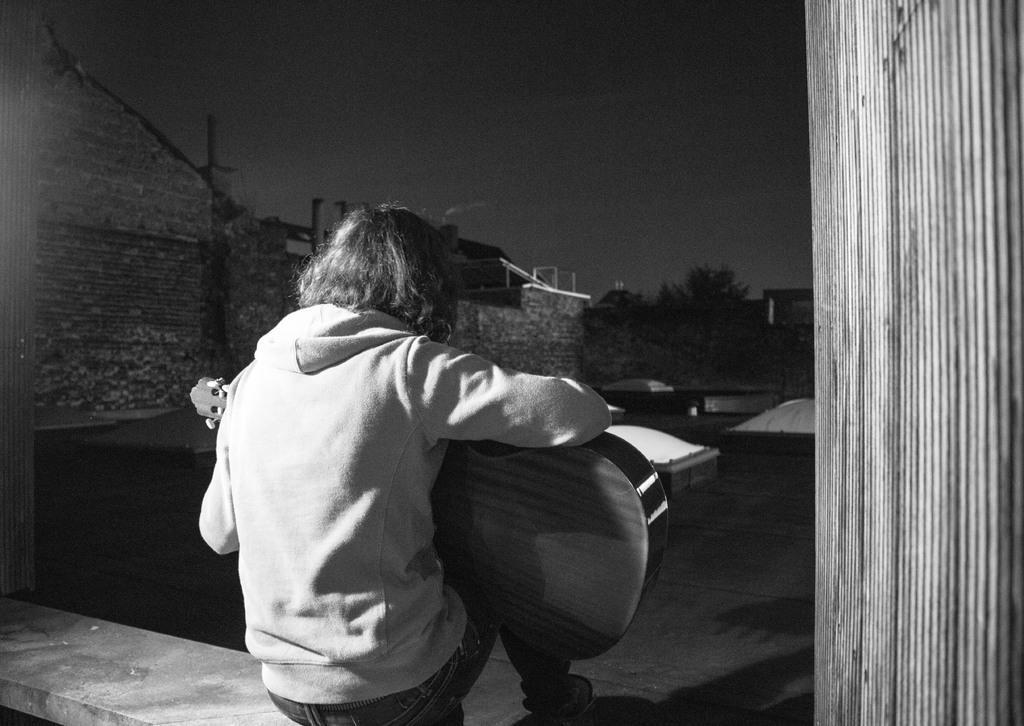Describe this image in one or two sentences. It is a black and white picture, a person is playing a guitar and on the left side there is a brick wall, beside the wall there are few trees. 